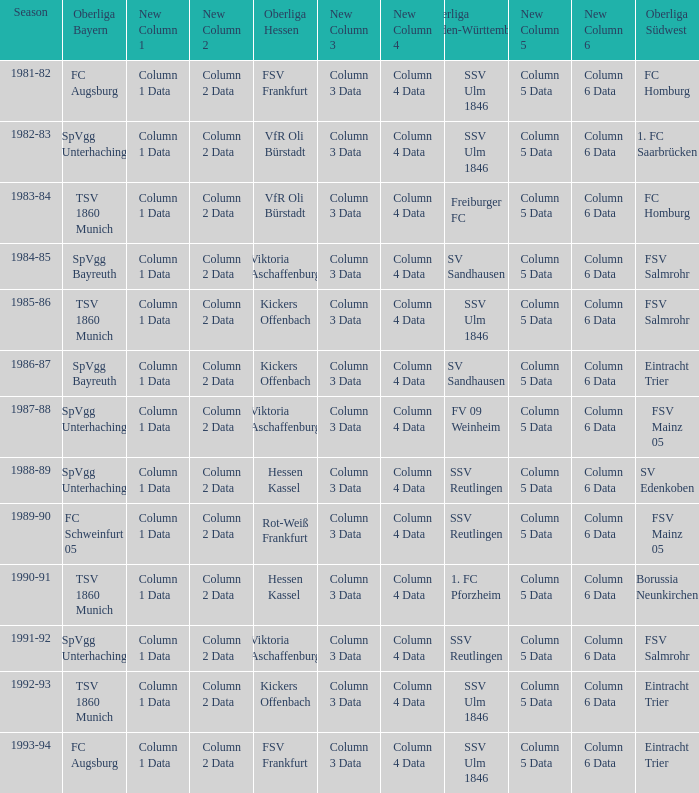Which oberliga baden-württemberg has a season of 1991-92? SSV Reutlingen. 